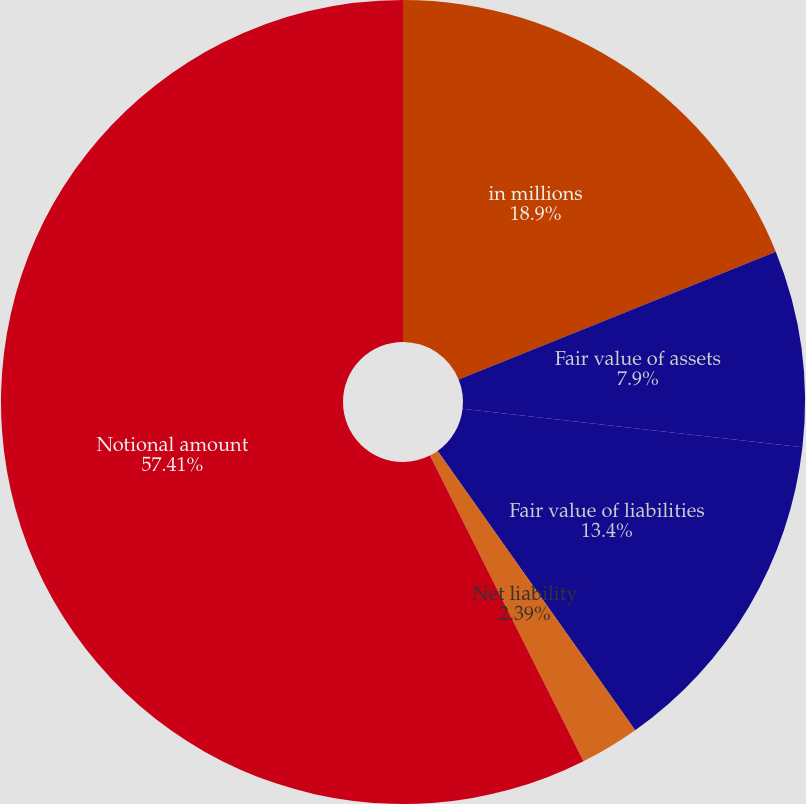Convert chart to OTSL. <chart><loc_0><loc_0><loc_500><loc_500><pie_chart><fcel>in millions<fcel>Fair value of assets<fcel>Fair value of liabilities<fcel>Net liability<fcel>Notional amount<nl><fcel>18.9%<fcel>7.9%<fcel>13.4%<fcel>2.39%<fcel>57.41%<nl></chart> 